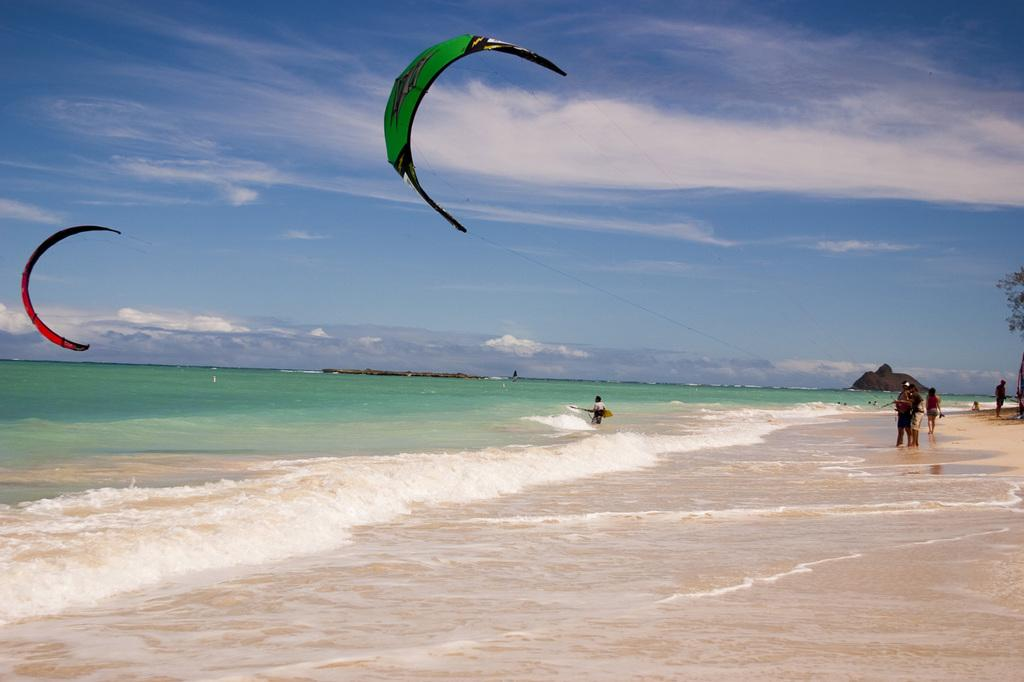Who or what can be seen in the image? There are people in the image. What type of landscape is visible in the image? There are hills in the image. What type of vegetation is present in the image? There are leaves in the image. What natural element is visible in the image? There is water visible in the image. What is the weather like in the image? The sky is cloudy in the image. What activity is taking place in the air? Paragliding is taking place in the air. How many boats can be seen in the image? There are no boats present in the image. What is the price of the paragliding experience in the image? The image does not provide information about the price of the paragliding experience. 